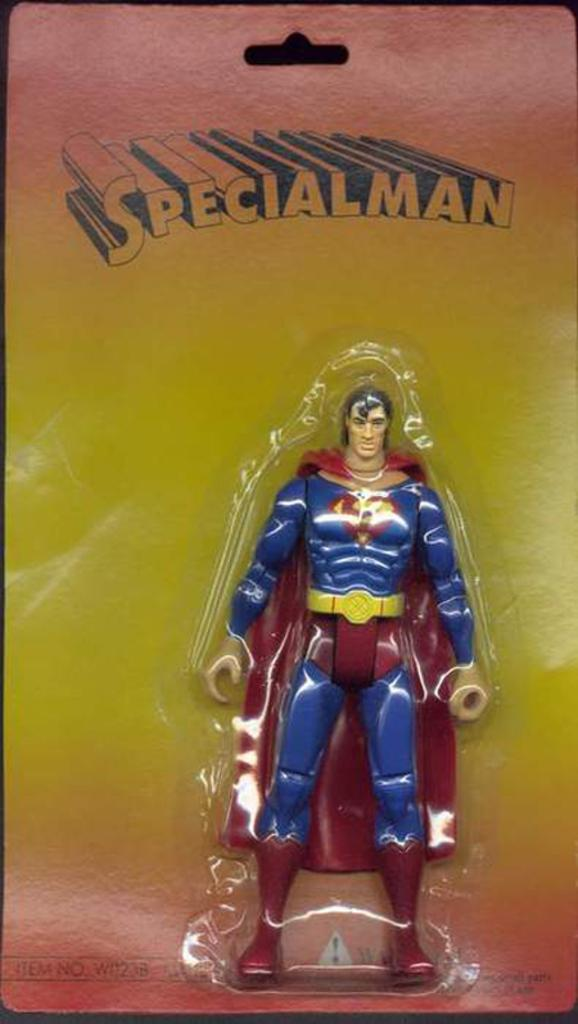What can be seen in the image that is meant for play or entertainment? There is a toy in the image. Where is the toy located? The toy is in an object. What additional information can be found on the object? There is writing on the object. How many tomatoes can be seen hanging from the toy in the image? There are no tomatoes present in the image, as the facts provided do not mention any tomatoes. 